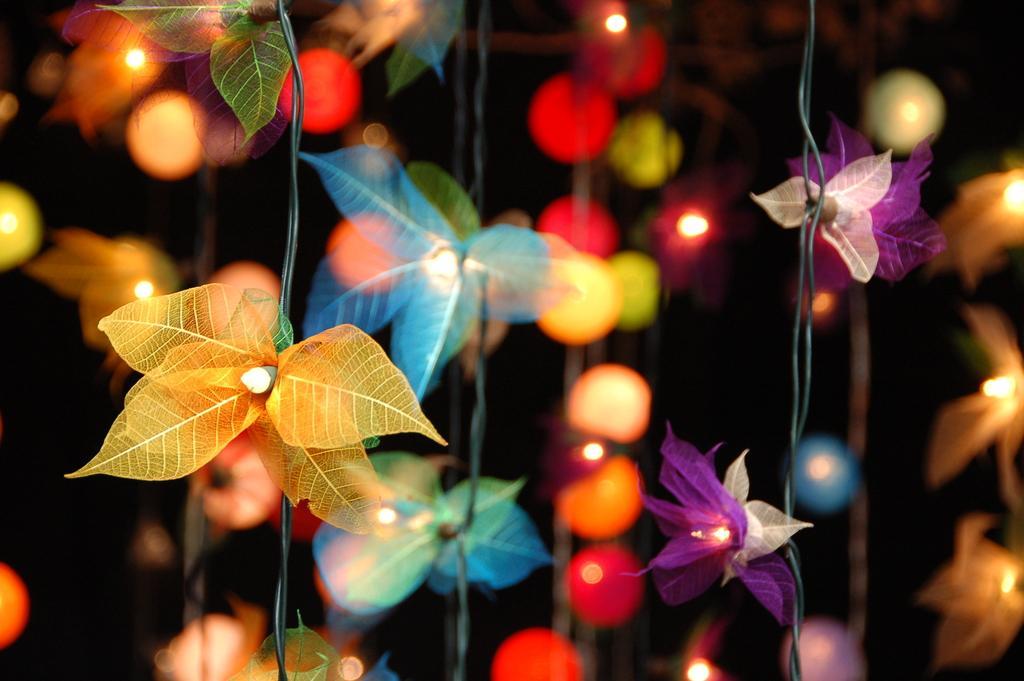How would you summarize this image in a sentence or two? In this picture we can see decorative items and lights. In the background of the image it is dark. 